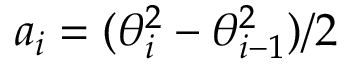<formula> <loc_0><loc_0><loc_500><loc_500>a _ { i } = ( \theta _ { i } ^ { 2 } - \theta _ { i - 1 } ^ { 2 } ) / 2</formula> 